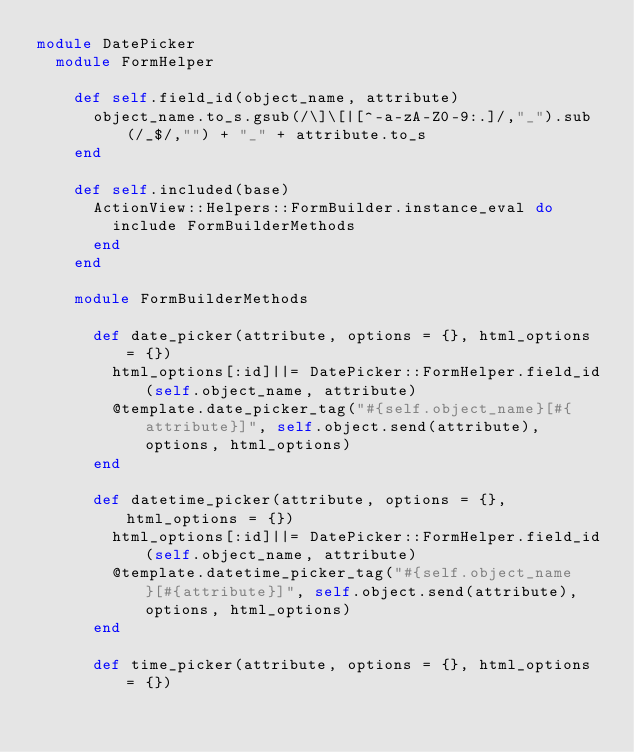Convert code to text. <code><loc_0><loc_0><loc_500><loc_500><_Ruby_>module DatePicker
  module FormHelper
    
    def self.field_id(object_name, attribute)
      object_name.to_s.gsub(/\]\[|[^-a-zA-Z0-9:.]/,"_").sub(/_$/,"") + "_" + attribute.to_s
    end
    
    def self.included(base)
      ActionView::Helpers::FormBuilder.instance_eval do
        include FormBuilderMethods
      end
    end
    
    module FormBuilderMethods
      
      def date_picker(attribute, options = {}, html_options = {})
        html_options[:id]||= DatePicker::FormHelper.field_id(self.object_name, attribute)
        @template.date_picker_tag("#{self.object_name}[#{attribute}]", self.object.send(attribute), options, html_options)
      end
      
      def datetime_picker(attribute, options = {}, html_options = {})
        html_options[:id]||= DatePicker::FormHelper.field_id(self.object_name, attribute)
        @template.datetime_picker_tag("#{self.object_name}[#{attribute}]", self.object.send(attribute), options, html_options)
      end
      
      def time_picker(attribute, options = {}, html_options = {})</code> 